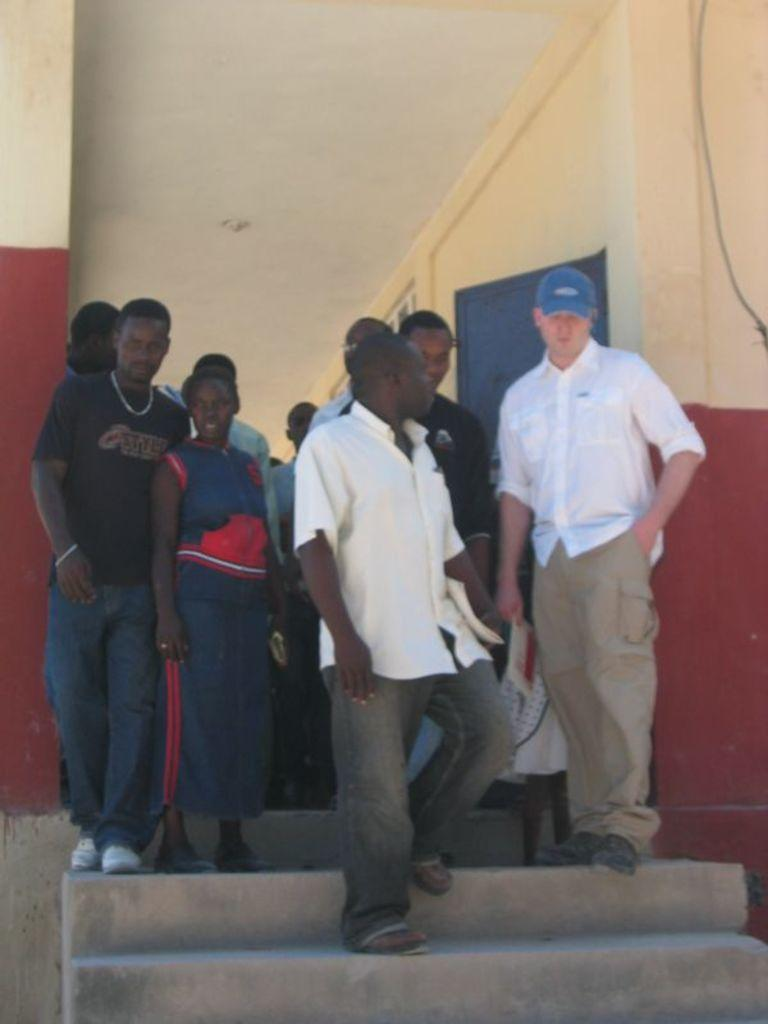What are the people in the image doing? The people in the image are on the stairs. What structure is visible in the image? There is a building in the image. What can be seen on the right side of the image? There is a wire on the right side of the image. How many dolls are sneezing on the stairs in the image? There are no dolls present in the image, and therefore no dolls sneezing on the stairs. 